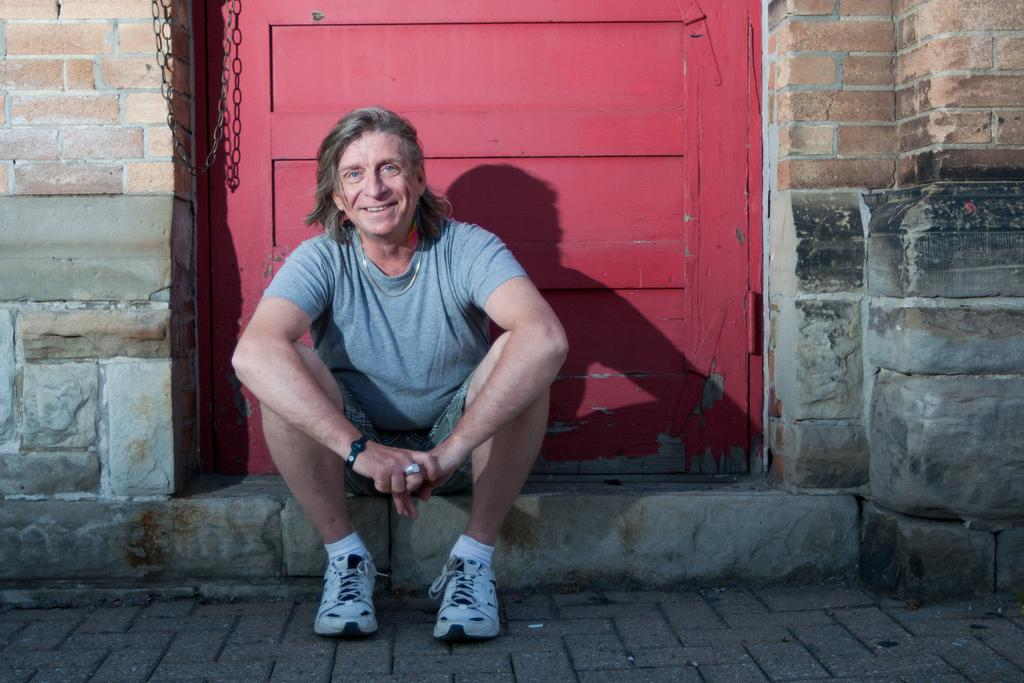What is the main subject of the image? There is a man sitting in the center of the image. What can be seen in the background of the image? There is a door, a wall, and a chain in the background of the image. What type of science experiment is being conducted by the secretary near the ocean in the image? There is no secretary, science experiment, or ocean present in the image. 